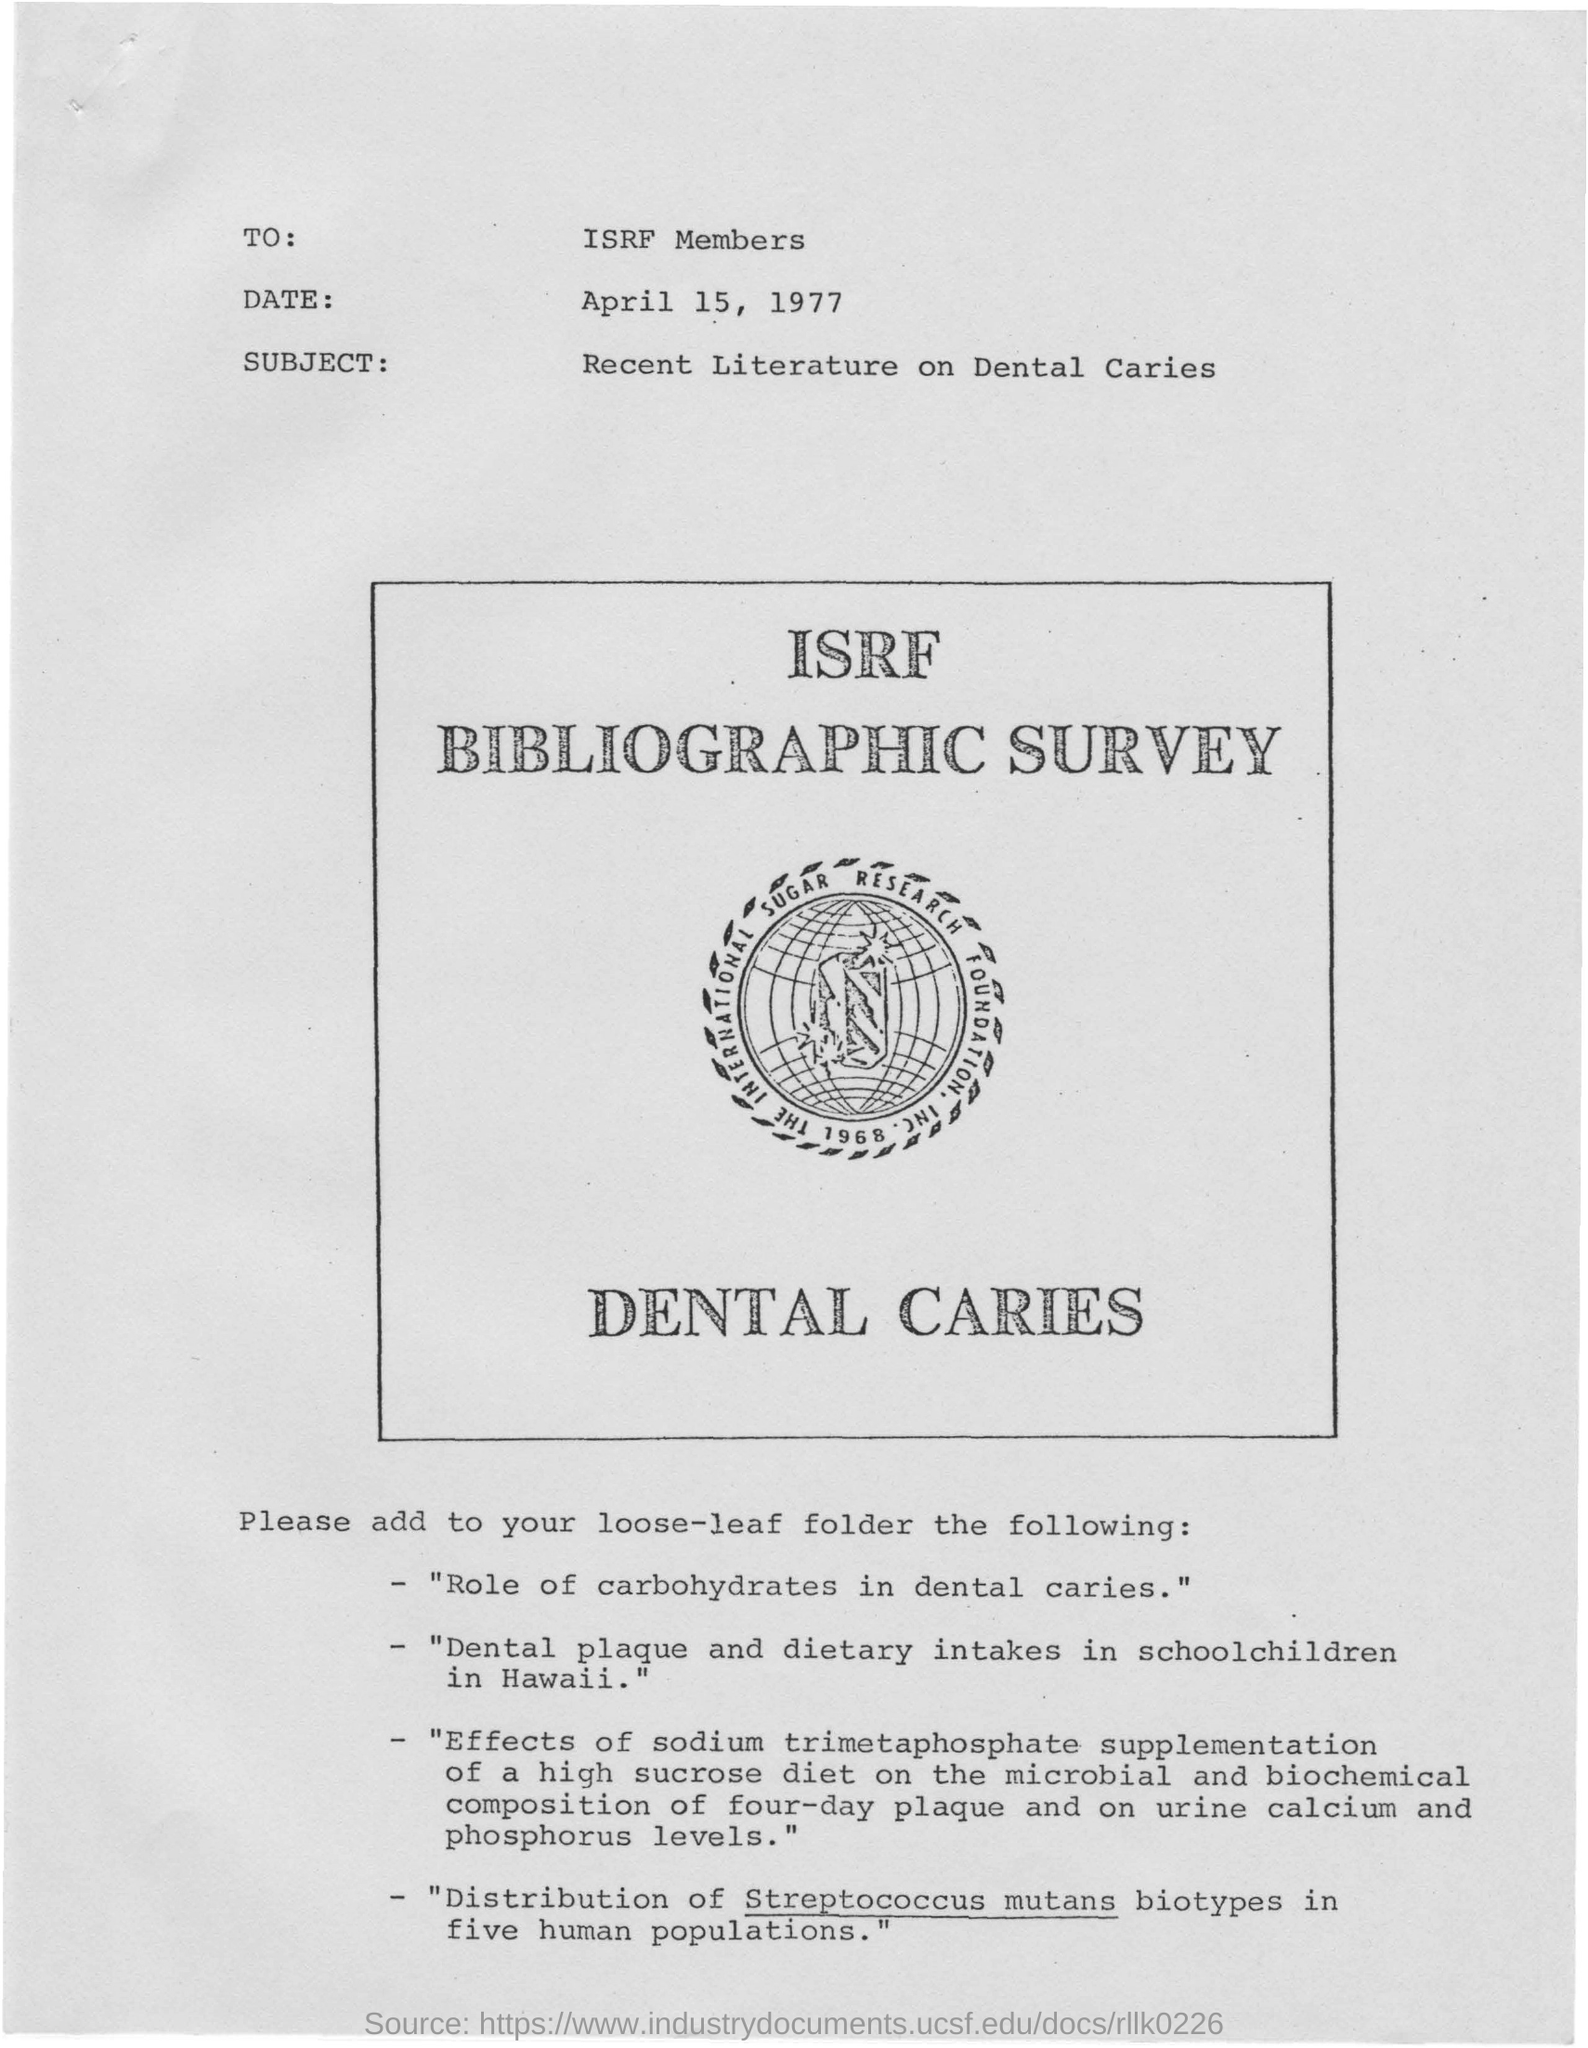Point out several critical features in this image. This document is addressed to the ISRF Members. The subject of the document is recent literature on dental caries. The date mentioned in this document is April 15, 1977. The distribution of streptococcus mutans biotypes occurs in five human populations. 